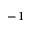Convert formula to latex. <formula><loc_0><loc_0><loc_500><loc_500>^ { - 1 }</formula> 